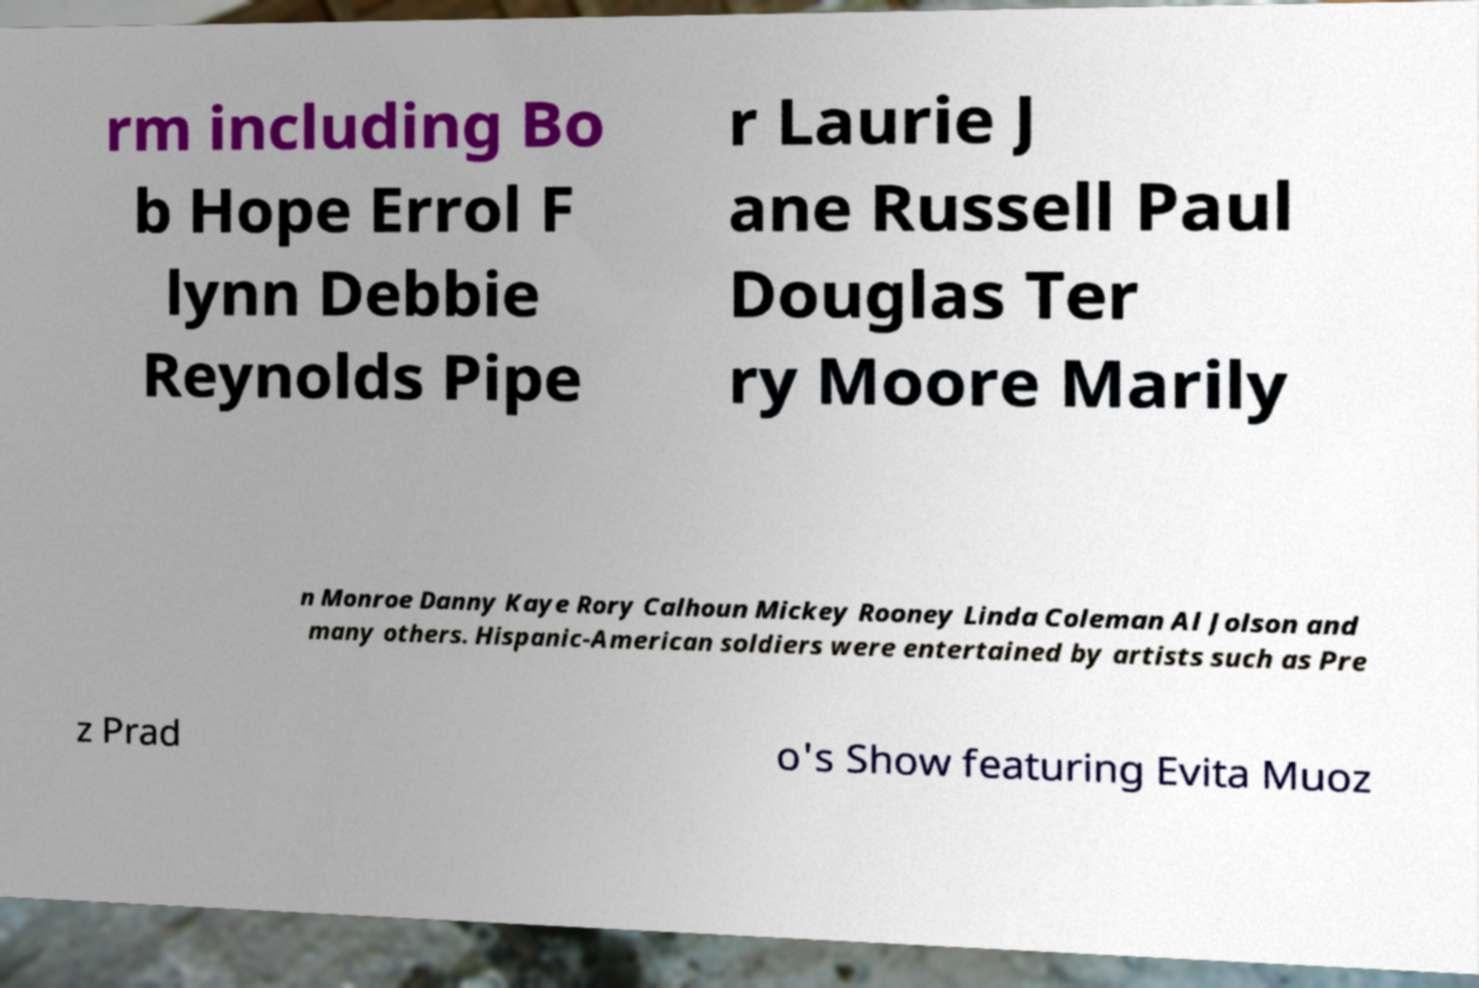I need the written content from this picture converted into text. Can you do that? rm including Bo b Hope Errol F lynn Debbie Reynolds Pipe r Laurie J ane Russell Paul Douglas Ter ry Moore Marily n Monroe Danny Kaye Rory Calhoun Mickey Rooney Linda Coleman Al Jolson and many others. Hispanic-American soldiers were entertained by artists such as Pre z Prad o's Show featuring Evita Muoz 